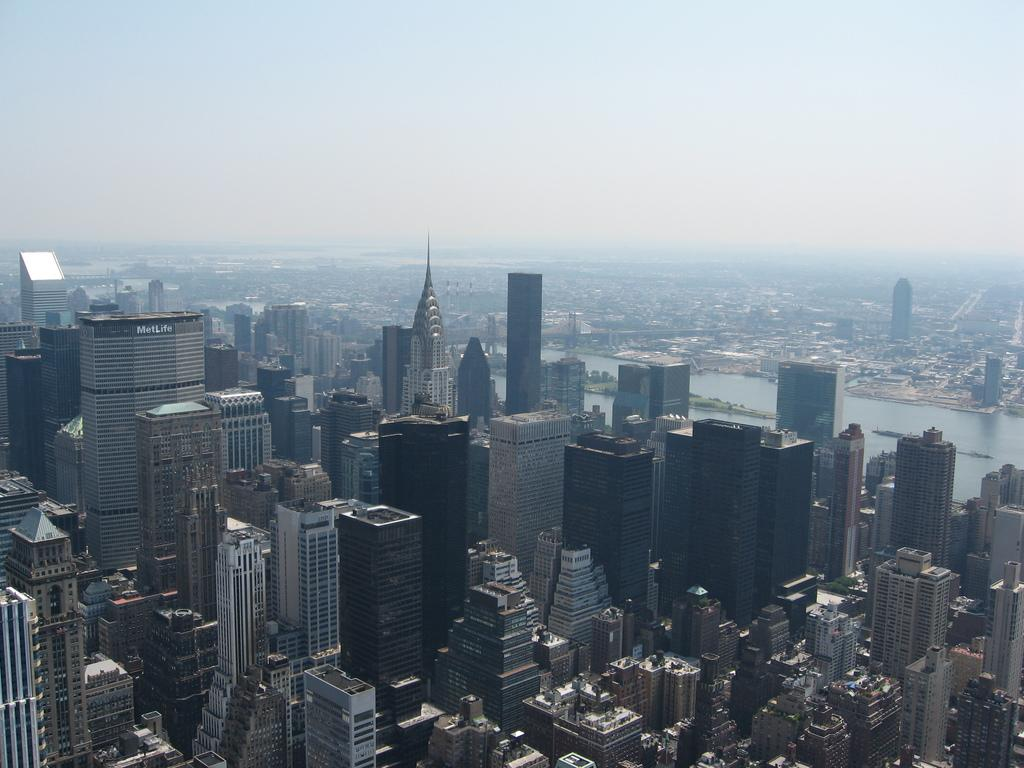What type of structures can be seen in the image? There are buildings in the image. What natural feature is present in the image? There is a lake in the image. What is the condition of the sky in the image? The sky is clear in the image. Where is the flower located in the image? There is no flower present in the image. Can you tell me how many rooms are visible in the image? There is no room visible in the image; it features buildings, a lake, and a clear sky. 